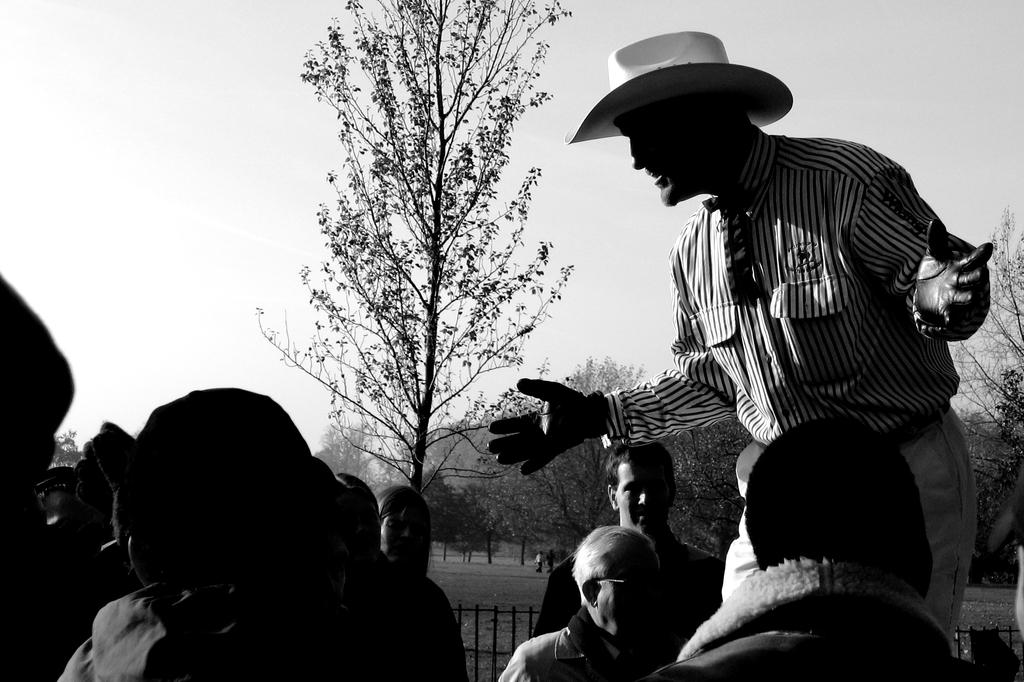How many people are in the image? There are people in the image, but the exact number is not specified. Can you describe the appearance of one of the people in the image? Yes, there is a person wearing a hat in the image. What can be seen beneath the people's feet in the image? The ground is visible in the image. What type of barrier is present in the image? There is fencing in the image. What type of vegetation is present in the image? Trees are present in the image. What is visible above the people's heads in the image? The sky is visible in the image. What type of substance is dripping from the icicle in the image? There is no icicle present in the image, so it is not possible to answer that question. 